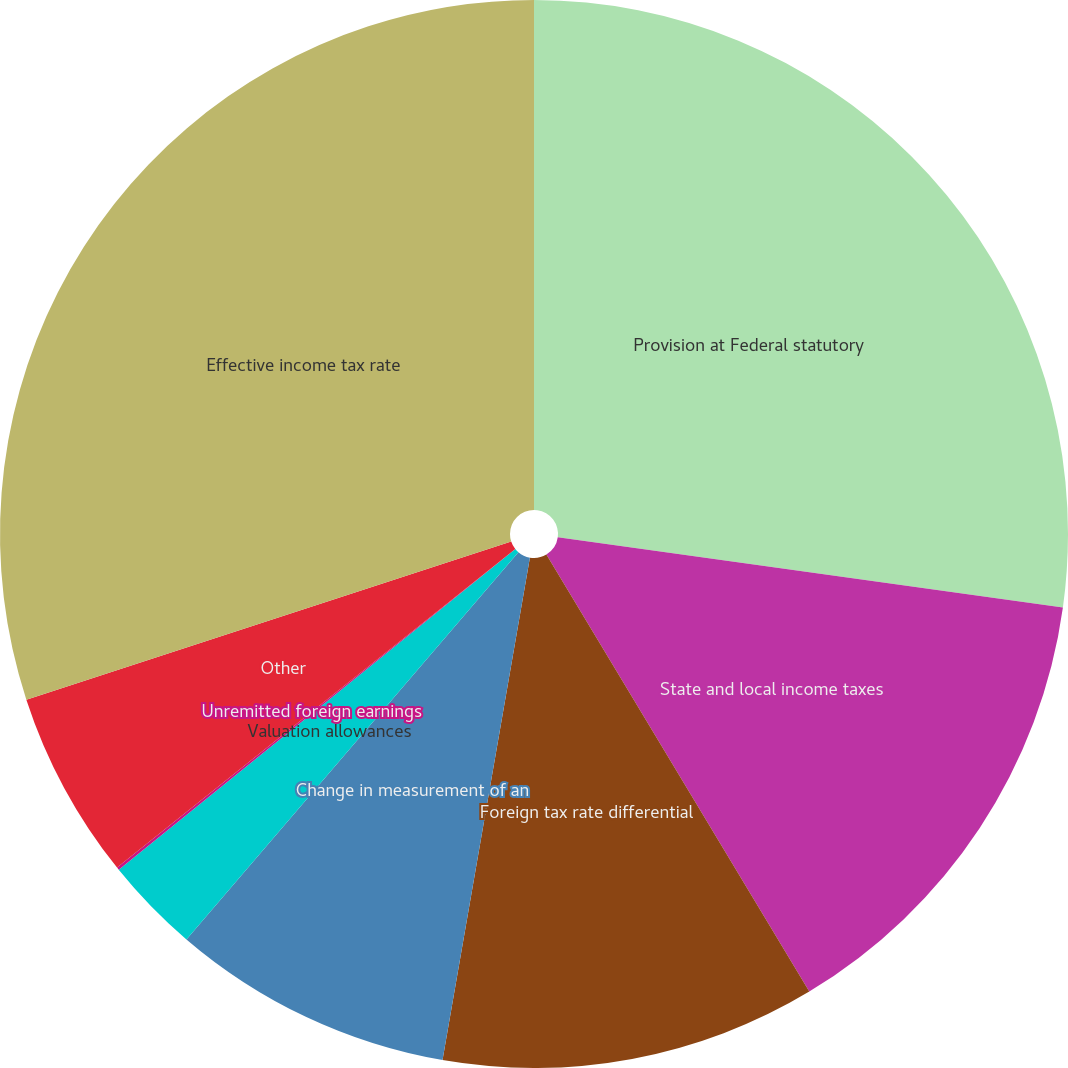<chart> <loc_0><loc_0><loc_500><loc_500><pie_chart><fcel>Provision at Federal statutory<fcel>State and local income taxes<fcel>Foreign tax rate differential<fcel>Change in measurement of an<fcel>Valuation allowances<fcel>Unremitted foreign earnings<fcel>Other<fcel>Effective income tax rate<nl><fcel>27.2%<fcel>14.18%<fcel>11.36%<fcel>8.54%<fcel>2.9%<fcel>0.08%<fcel>5.72%<fcel>30.02%<nl></chart> 